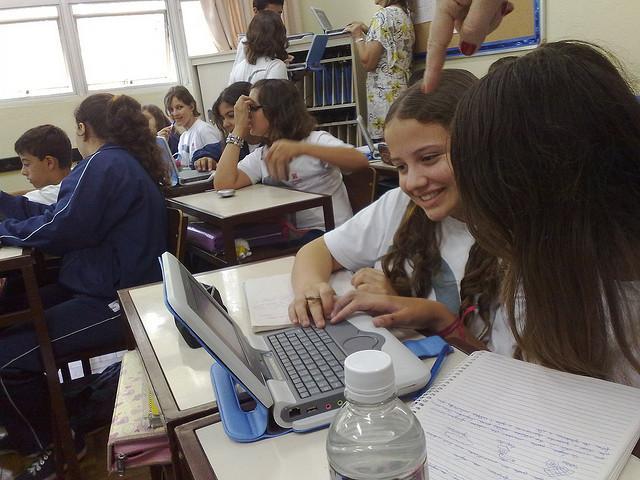Who is probably pointing above the students? Please explain your reasoning. teacher. The students look to be sitting at a desk in a classroom, and the pointed finger seems to belong to an older person. the only older person typically in a classroom would be the teacher. 